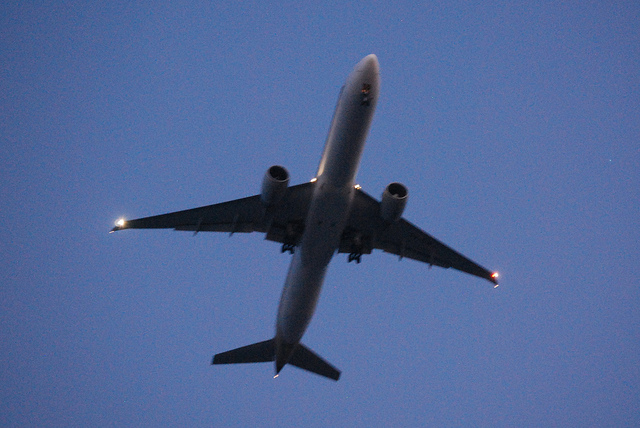<image>How many different colors is this airplane? I don't know how many different colors the airplane is. It might be one or two. How many different colors is this airplane? I am not sure how many different colors this airplane has. It can be either 1 or 2. 